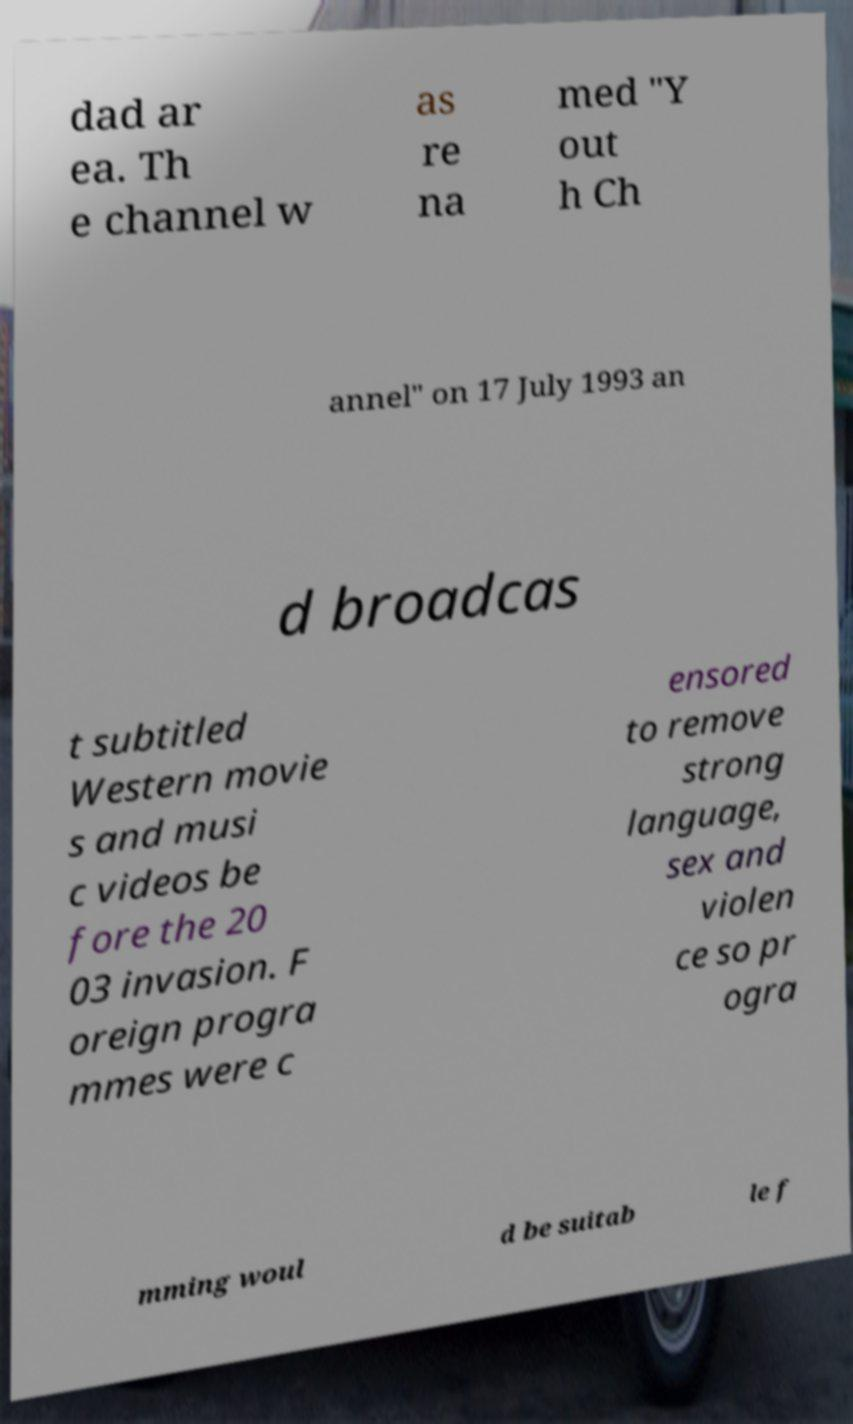What messages or text are displayed in this image? I need them in a readable, typed format. dad ar ea. Th e channel w as re na med "Y out h Ch annel" on 17 July 1993 an d broadcas t subtitled Western movie s and musi c videos be fore the 20 03 invasion. F oreign progra mmes were c ensored to remove strong language, sex and violen ce so pr ogra mming woul d be suitab le f 